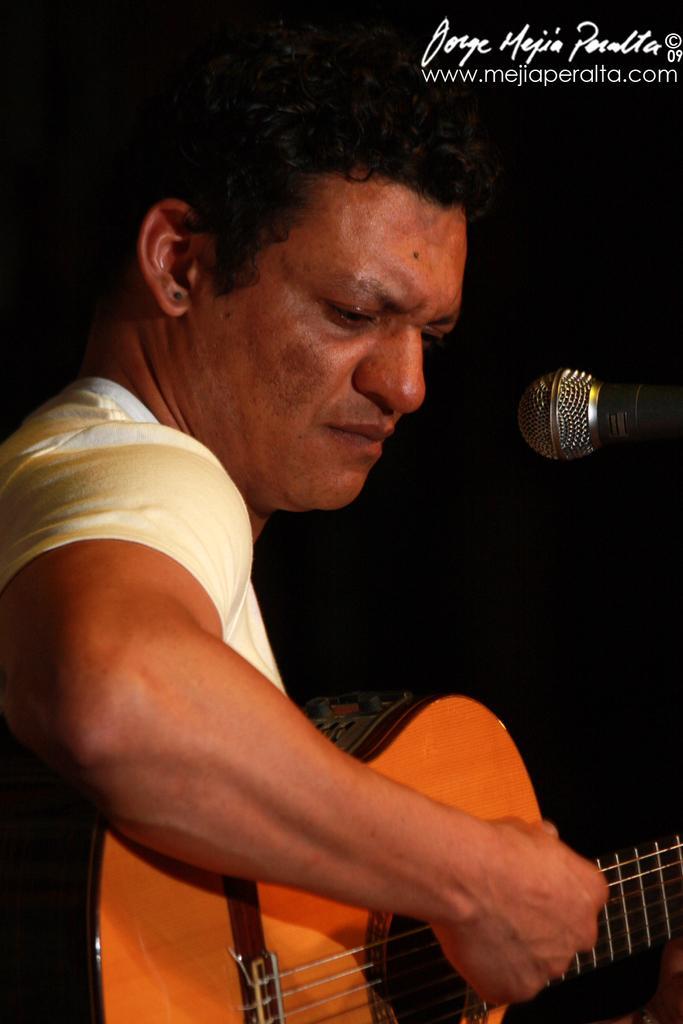Can you describe this image briefly? In this image I c. an see a man playing a guitar in front of a microphone 